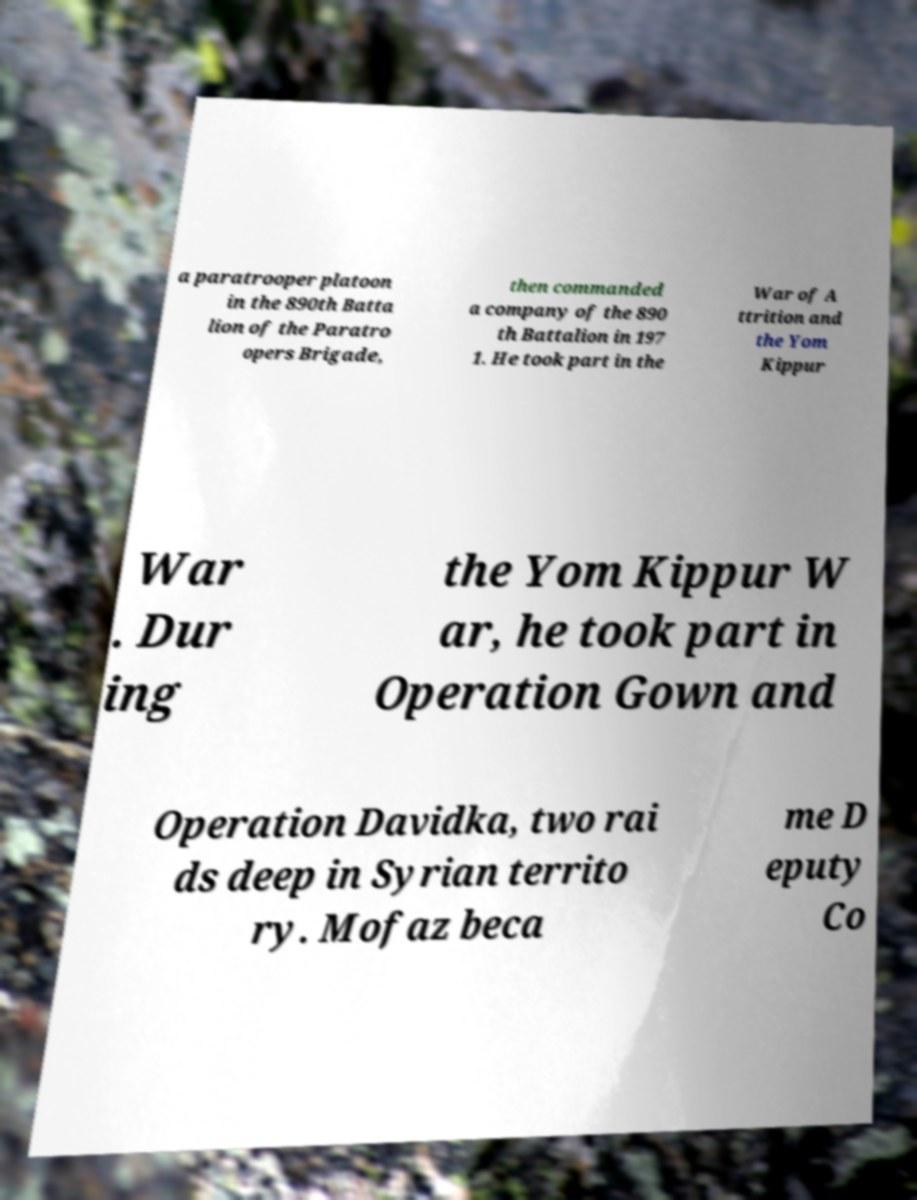What messages or text are displayed in this image? I need them in a readable, typed format. a paratrooper platoon in the 890th Batta lion of the Paratro opers Brigade, then commanded a company of the 890 th Battalion in 197 1. He took part in the War of A ttrition and the Yom Kippur War . Dur ing the Yom Kippur W ar, he took part in Operation Gown and Operation Davidka, two rai ds deep in Syrian territo ry. Mofaz beca me D eputy Co 